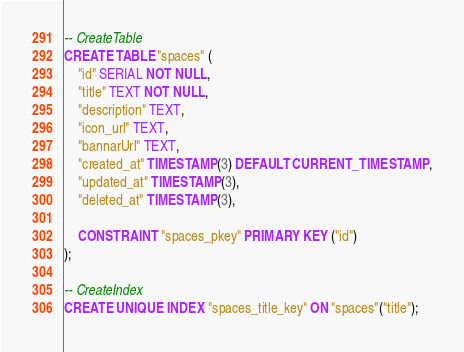Convert code to text. <code><loc_0><loc_0><loc_500><loc_500><_SQL_>-- CreateTable
CREATE TABLE "spaces" (
    "id" SERIAL NOT NULL,
    "title" TEXT NOT NULL,
    "description" TEXT,
    "icon_url" TEXT,
    "bannarUrl" TEXT,
    "created_at" TIMESTAMP(3) DEFAULT CURRENT_TIMESTAMP,
    "updated_at" TIMESTAMP(3),
    "deleted_at" TIMESTAMP(3),

    CONSTRAINT "spaces_pkey" PRIMARY KEY ("id")
);

-- CreateIndex
CREATE UNIQUE INDEX "spaces_title_key" ON "spaces"("title");
</code> 